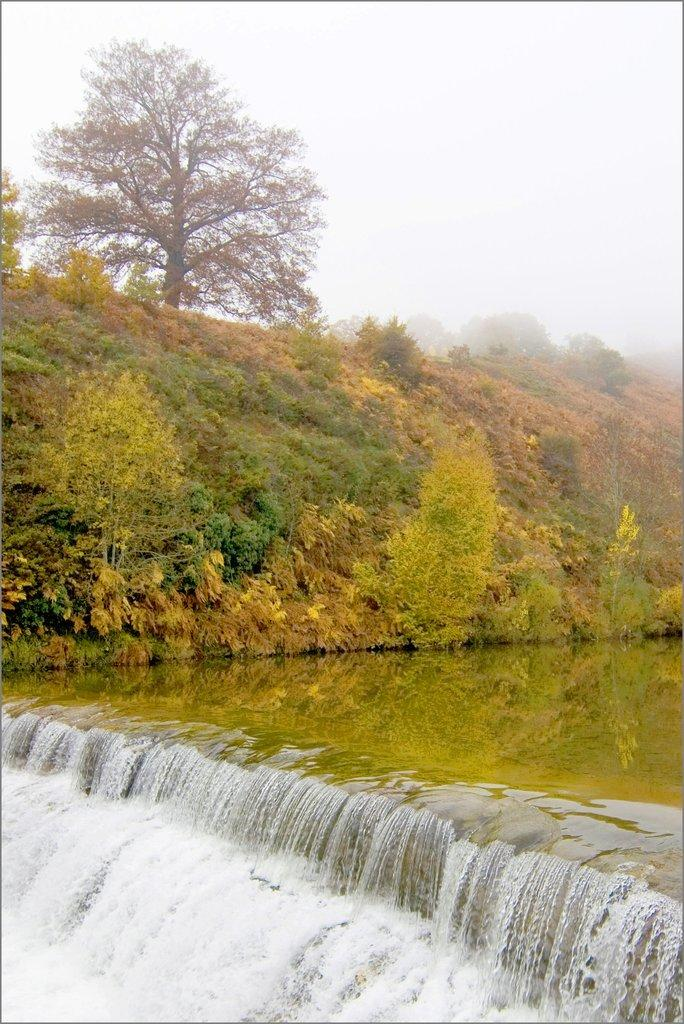What type of natural feature is present in the image? There is a river in the image. What is happening to the water in the river? Water flow is visible in the image. What can be seen above the river in the image? The sky is visible in the image, and clouds are present in the sky. What type of vegetation is visible in the background of the image? Trees, plants, and grass are present in the background of the image. What type of voice can be heard coming from the ducks in the image? There are no ducks present in the image, so it is not possible to determine what type of voice might be heard. 